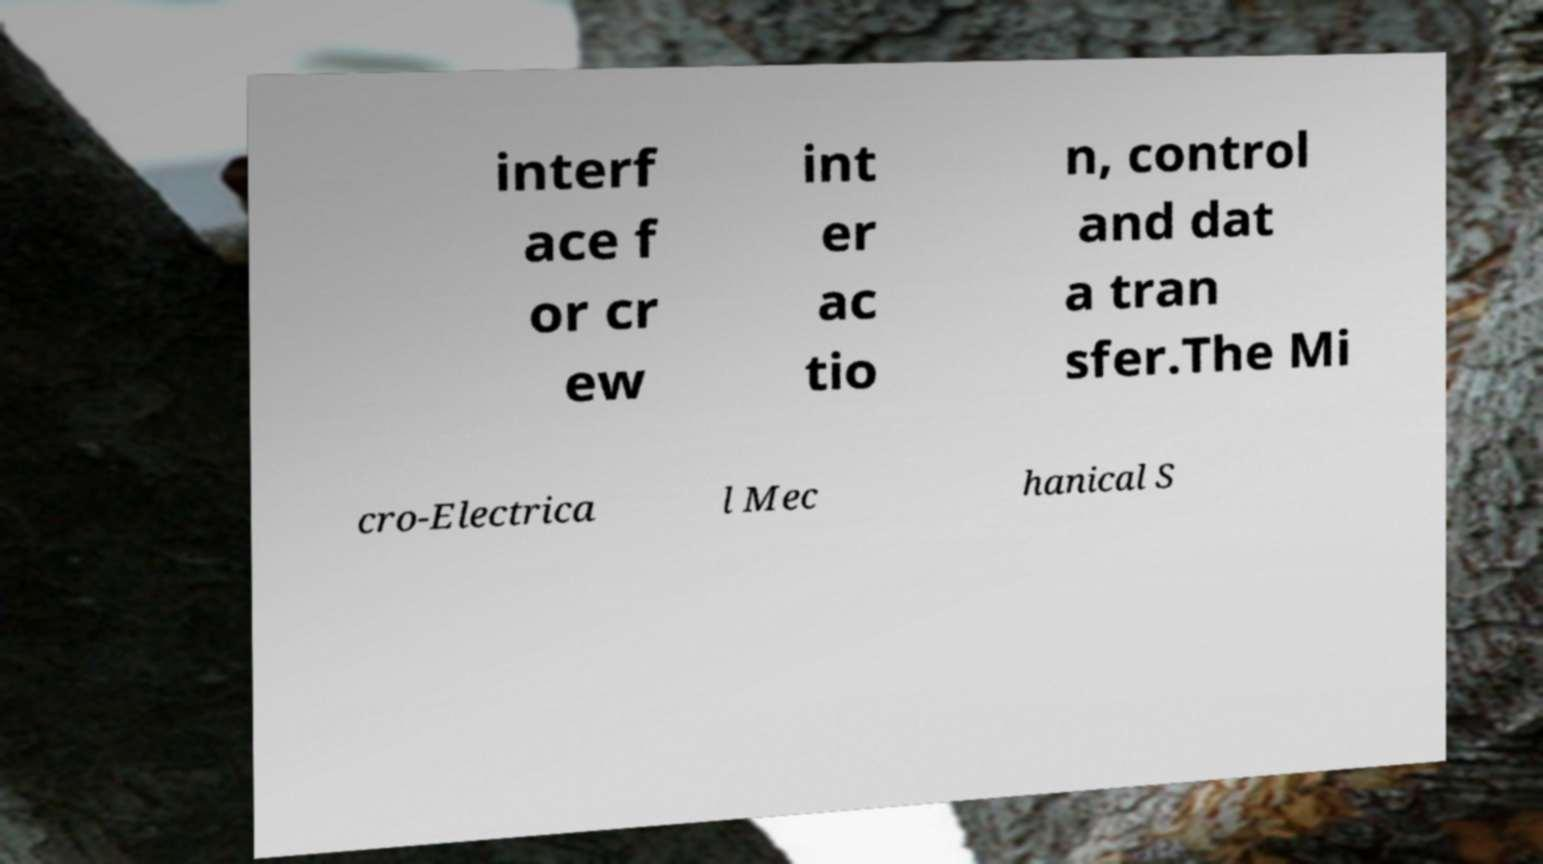Please identify and transcribe the text found in this image. interf ace f or cr ew int er ac tio n, control and dat a tran sfer.The Mi cro-Electrica l Mec hanical S 